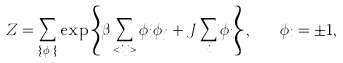Convert formula to latex. <formula><loc_0><loc_0><loc_500><loc_500>Z = \sum _ { \{ \phi _ { i } \} } \exp \left \{ \beta \sum _ { < i j > } \phi _ { i } \phi _ { j } + J \sum _ { i } \phi _ { i } \right \} , \quad \phi _ { i } = \pm 1 ,</formula> 